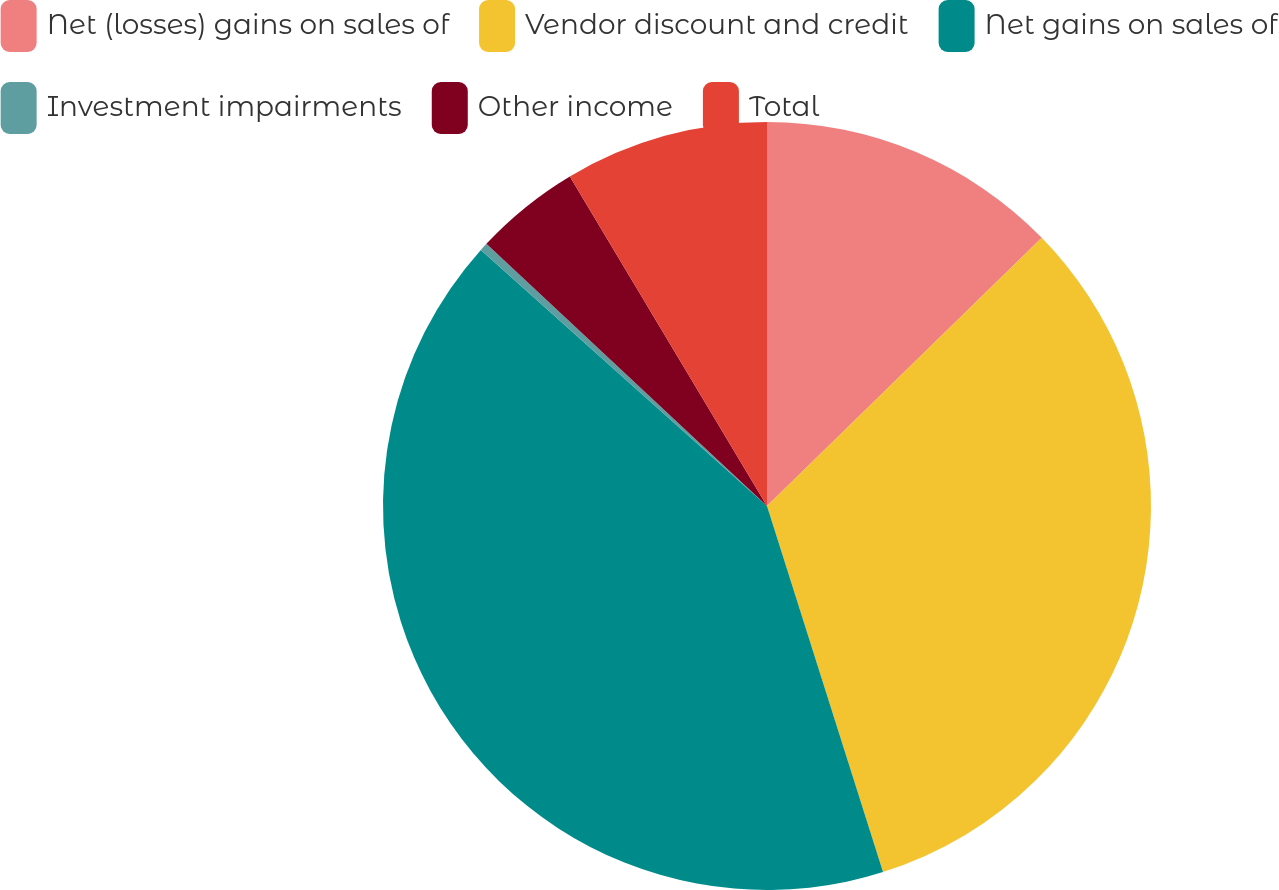Convert chart to OTSL. <chart><loc_0><loc_0><loc_500><loc_500><pie_chart><fcel>Net (losses) gains on sales of<fcel>Vendor discount and credit<fcel>Net gains on sales of<fcel>Investment impairments<fcel>Other income<fcel>Total<nl><fcel>12.69%<fcel>32.42%<fcel>41.5%<fcel>0.34%<fcel>4.46%<fcel>8.58%<nl></chart> 